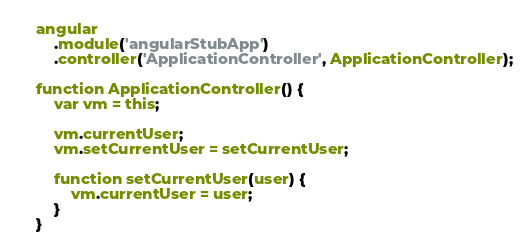Convert code to text. <code><loc_0><loc_0><loc_500><loc_500><_JavaScript_>
    angular
        .module('angularStubApp')
        .controller('ApplicationController', ApplicationController);

    function ApplicationController() {
        var vm = this;

        vm.currentUser;
        vm.setCurrentUser = setCurrentUser;

        function setCurrentUser(user) {
            vm.currentUser = user;
        }
    }</code> 